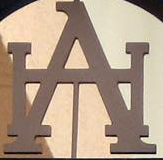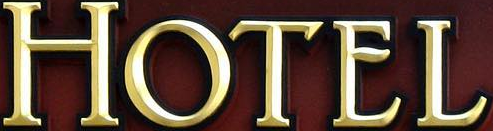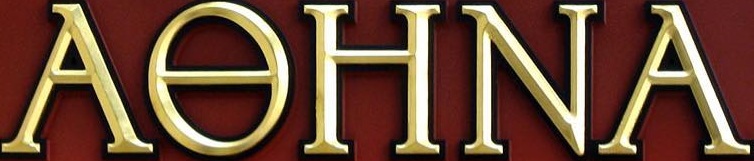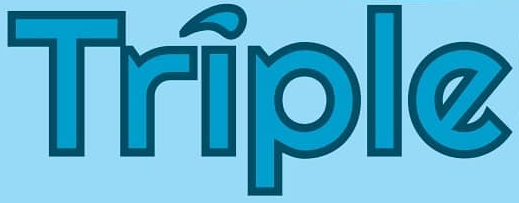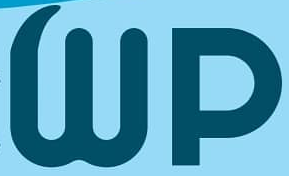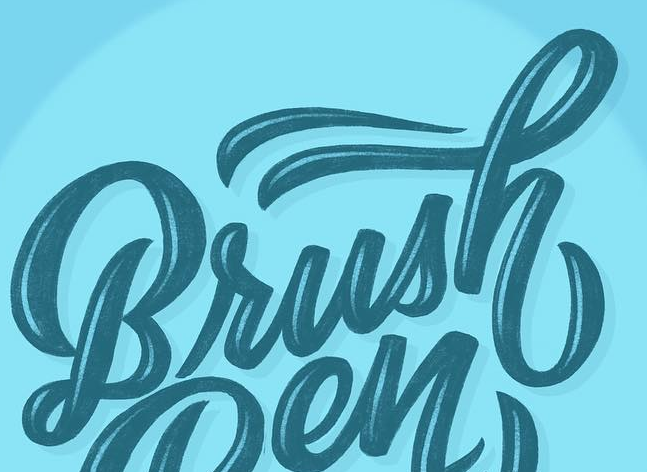What text appears in these images from left to right, separated by a semicolon? HA; HOTEL; AƟHNA; Triple; Wp; Brush 